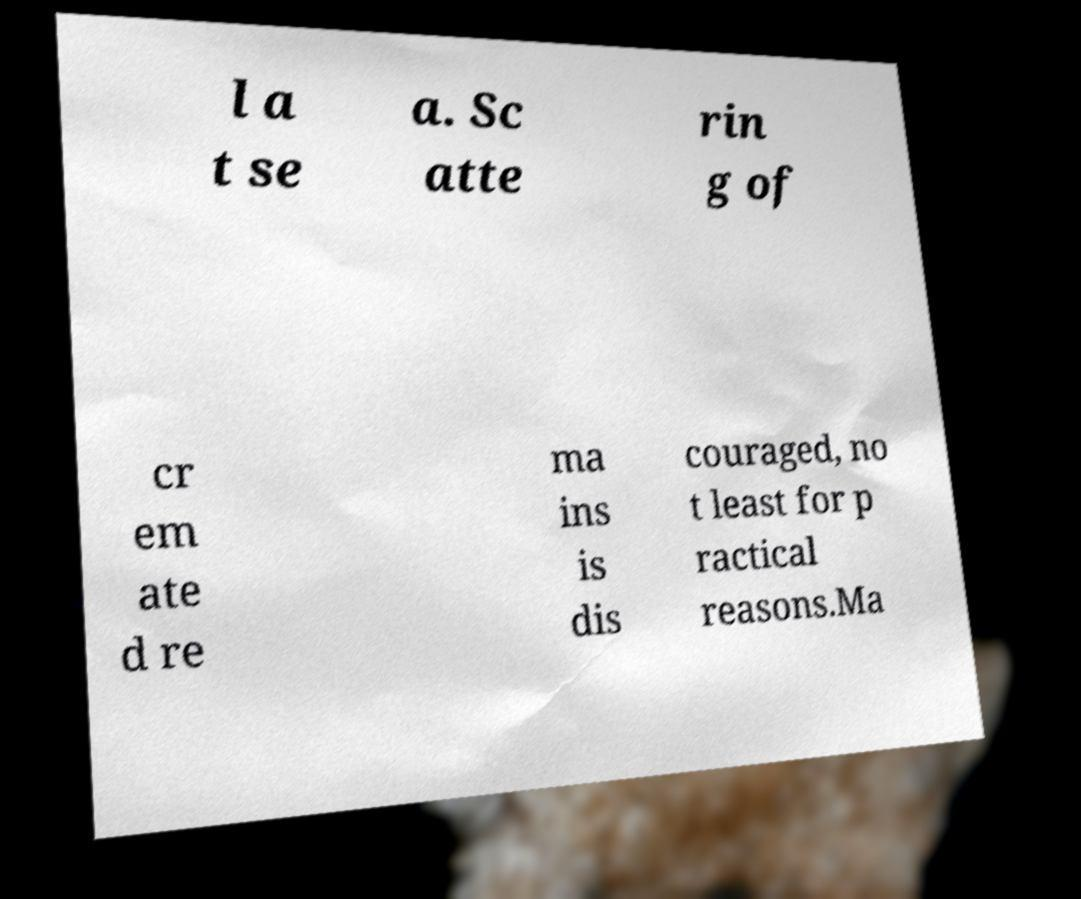Please read and relay the text visible in this image. What does it say? l a t se a. Sc atte rin g of cr em ate d re ma ins is dis couraged, no t least for p ractical reasons.Ma 